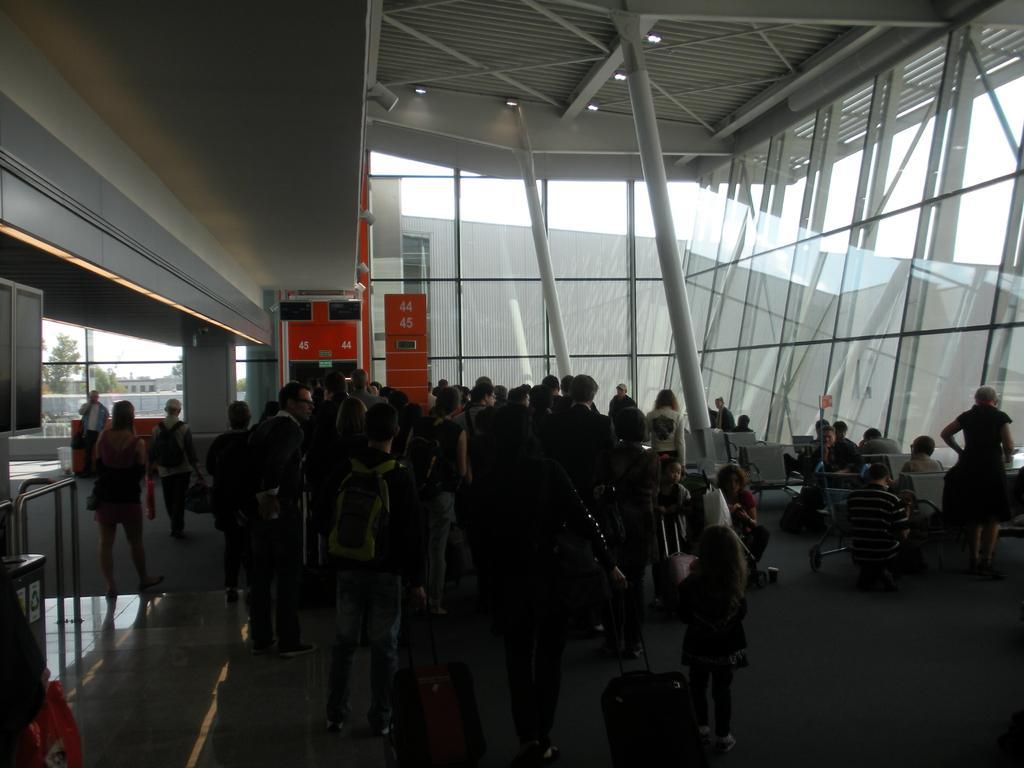Describe this image in one or two sentences. In this image, there are a few people. We can see the ground with some objects. We can also see some chairs and a few poles. We can also see some glass and some objects on the left. We can also see some red colored objects and the roof with some lights. We can also see the sky. 